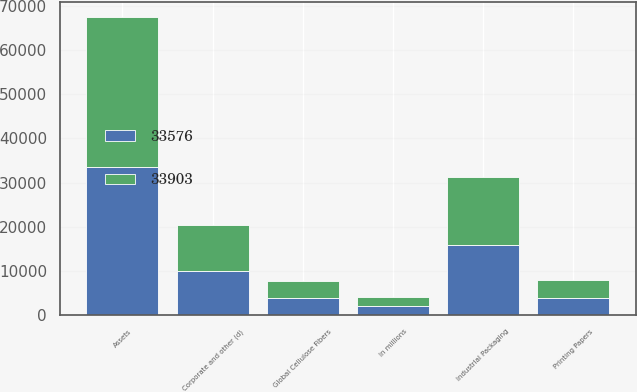<chart> <loc_0><loc_0><loc_500><loc_500><stacked_bar_chart><ecel><fcel>In millions<fcel>Industrial Packaging<fcel>Global Cellulose Fibers<fcel>Printing Papers<fcel>Corporate and other (d)<fcel>Assets<nl><fcel>33576<fcel>2018<fcel>15859<fcel>3880<fcel>3905<fcel>9932<fcel>33576<nl><fcel>33903<fcel>2017<fcel>15354<fcel>3913<fcel>4054<fcel>10582<fcel>33903<nl></chart> 